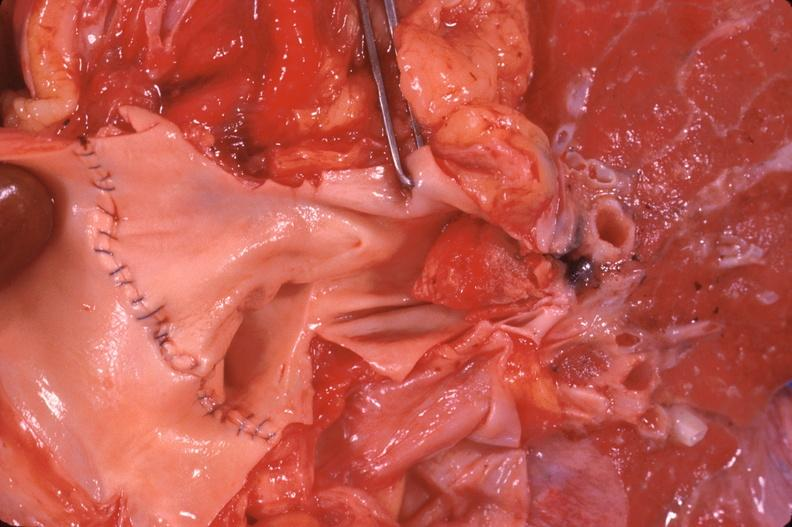does this image show thromboembolus from leg veins in pulmonary artery?
Answer the question using a single word or phrase. Yes 